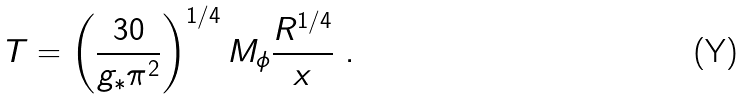<formula> <loc_0><loc_0><loc_500><loc_500>T = \left ( \frac { 3 0 } { g _ { * } \pi ^ { 2 } } \right ) ^ { 1 / 4 } M _ { \phi } \frac { R ^ { 1 / 4 } } { x } \ .</formula> 